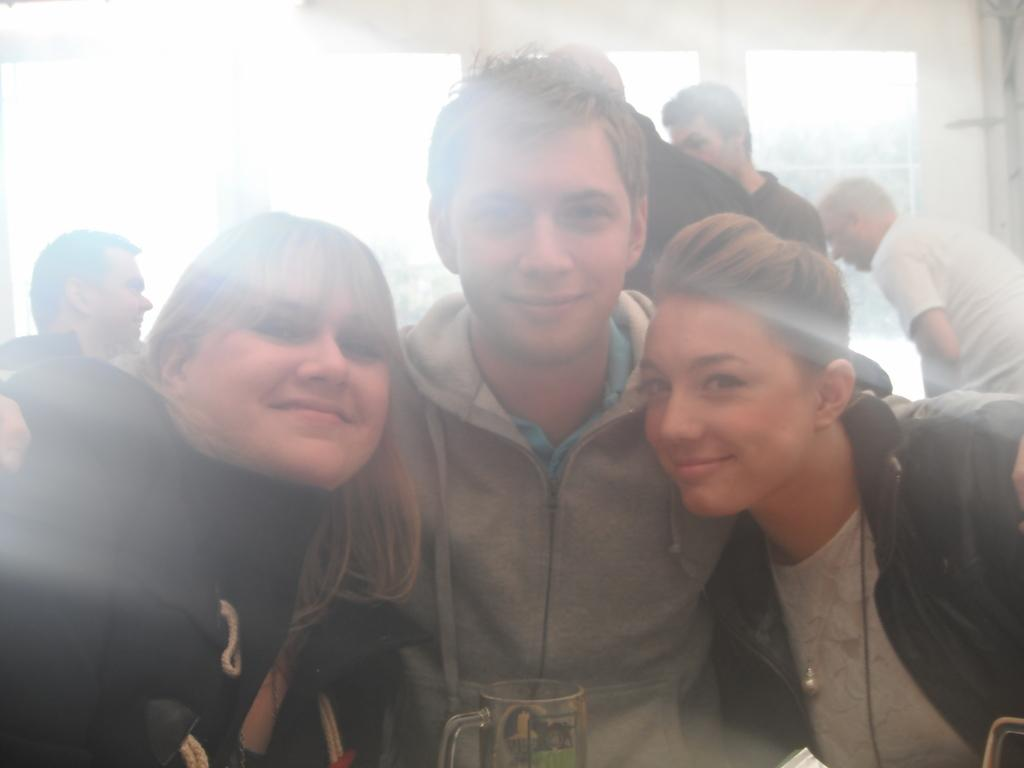How many people are in the image? There is a group of people in the image, but the exact number cannot be determined from the provided facts. Can you describe the arrangement of the people in the image? The people are scattered throughout the image. What object is located in the front of the image? There is a cup in the front of the image. What can be seen in the background of the image? There is a window and a wall in the background of the image. What type of stew is being served in the image? There is no stew present in the image. Can you describe the behavior of the rat in the image? There is no rat present in the image. 